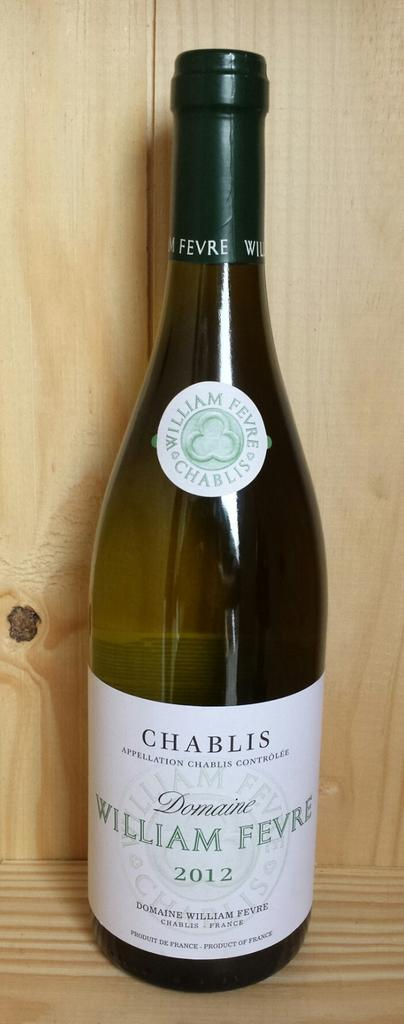<image>
Present a compact description of the photo's key features. Bottle of alcohol that says the word CHABLIS on top. 